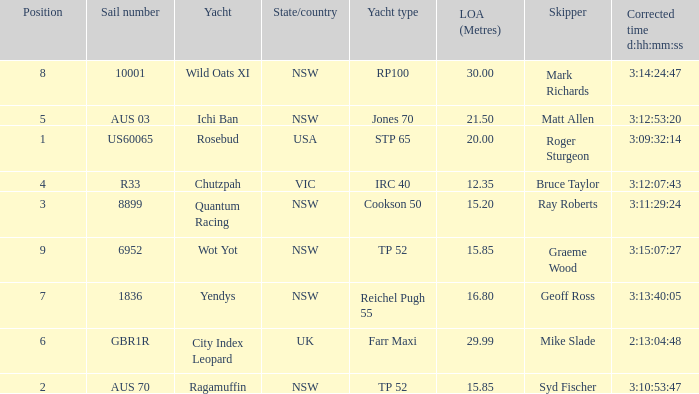How many yachts had a position of 3? 1.0. 